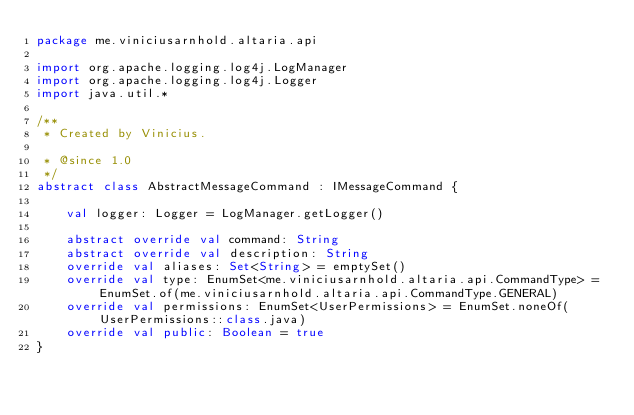Convert code to text. <code><loc_0><loc_0><loc_500><loc_500><_Kotlin_>package me.viniciusarnhold.altaria.api

import org.apache.logging.log4j.LogManager
import org.apache.logging.log4j.Logger
import java.util.*

/**
 * Created by Vinicius.

 * @since 1.0
 */
abstract class AbstractMessageCommand : IMessageCommand {

    val logger: Logger = LogManager.getLogger()

    abstract override val command: String
    abstract override val description: String
    override val aliases: Set<String> = emptySet()
    override val type: EnumSet<me.viniciusarnhold.altaria.api.CommandType> = EnumSet.of(me.viniciusarnhold.altaria.api.CommandType.GENERAL)
    override val permissions: EnumSet<UserPermissions> = EnumSet.noneOf(UserPermissions::class.java)
    override val public: Boolean = true
}
</code> 